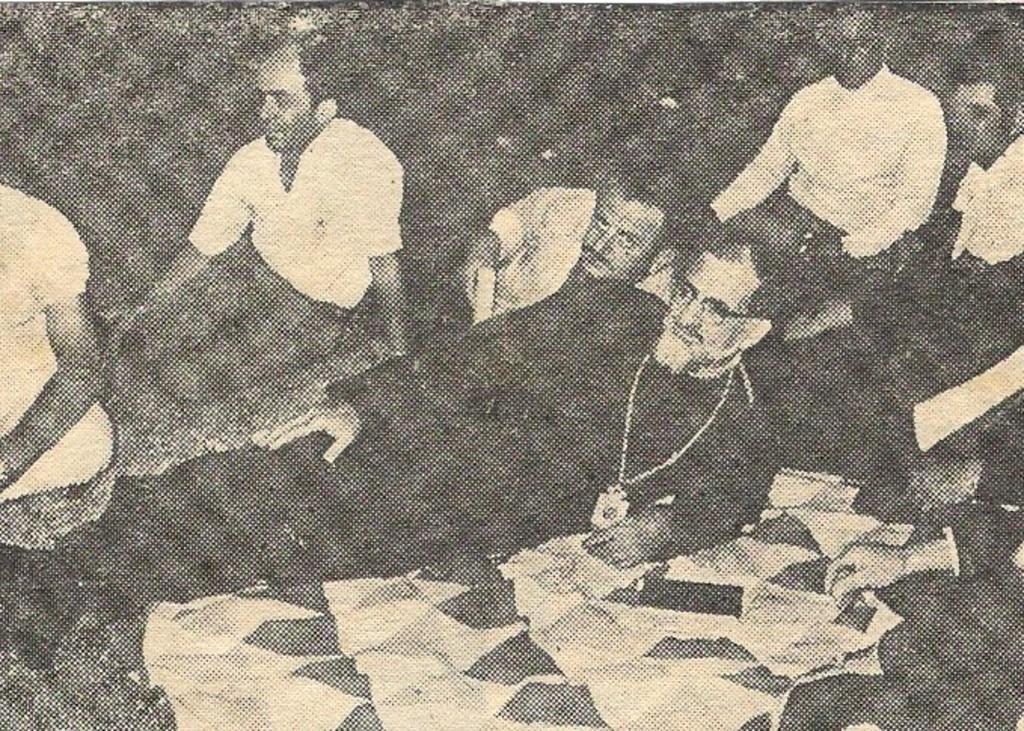In one or two sentences, can you explain what this image depicts? This is a black and white picture. In this picture we can see a person lying on the ground. We can see a few people behind this person from left to right. 